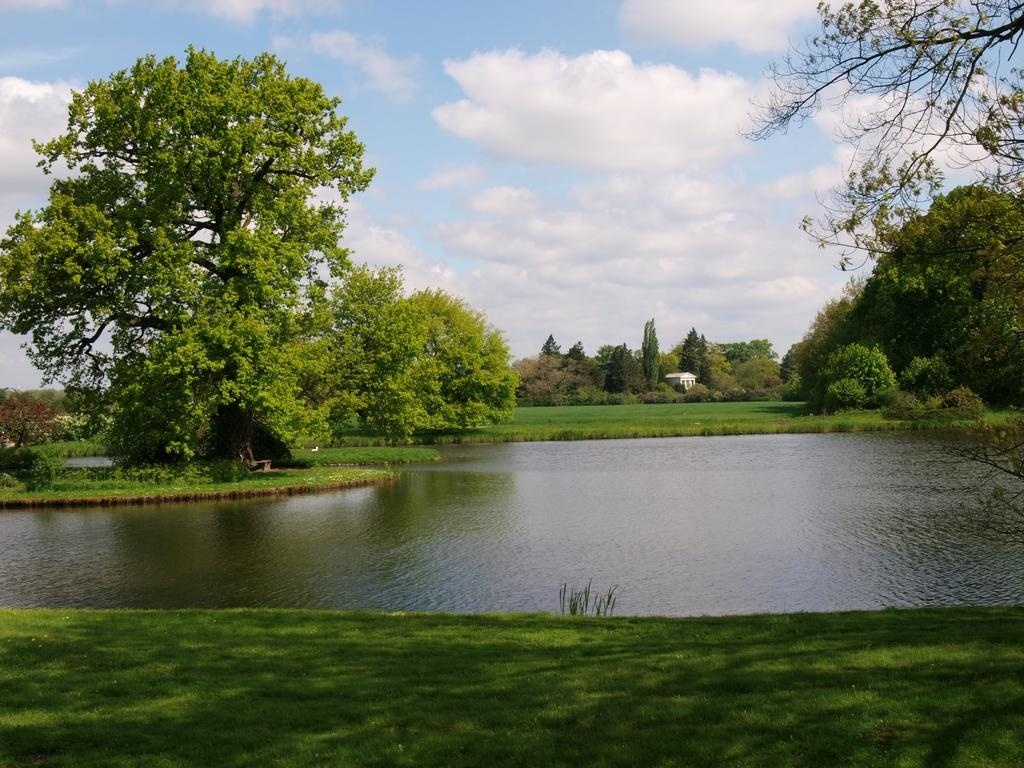What type of vegetation is at the bottom of the image? There is grass at the bottom of the image. What can be seen in the background of the image? There are trees and a building in the background of the image. What is visible in the middle of the image? There is water visible in the middle of the image. What is visible at the top of the image? The sky is visible at the top of the image. What type of line can be seen comfortably drinking a drink in the image? There is no line or person drinking a drink present in the image. What type of comfort can be seen in the image? The image does not depict any specific type of comfort. 